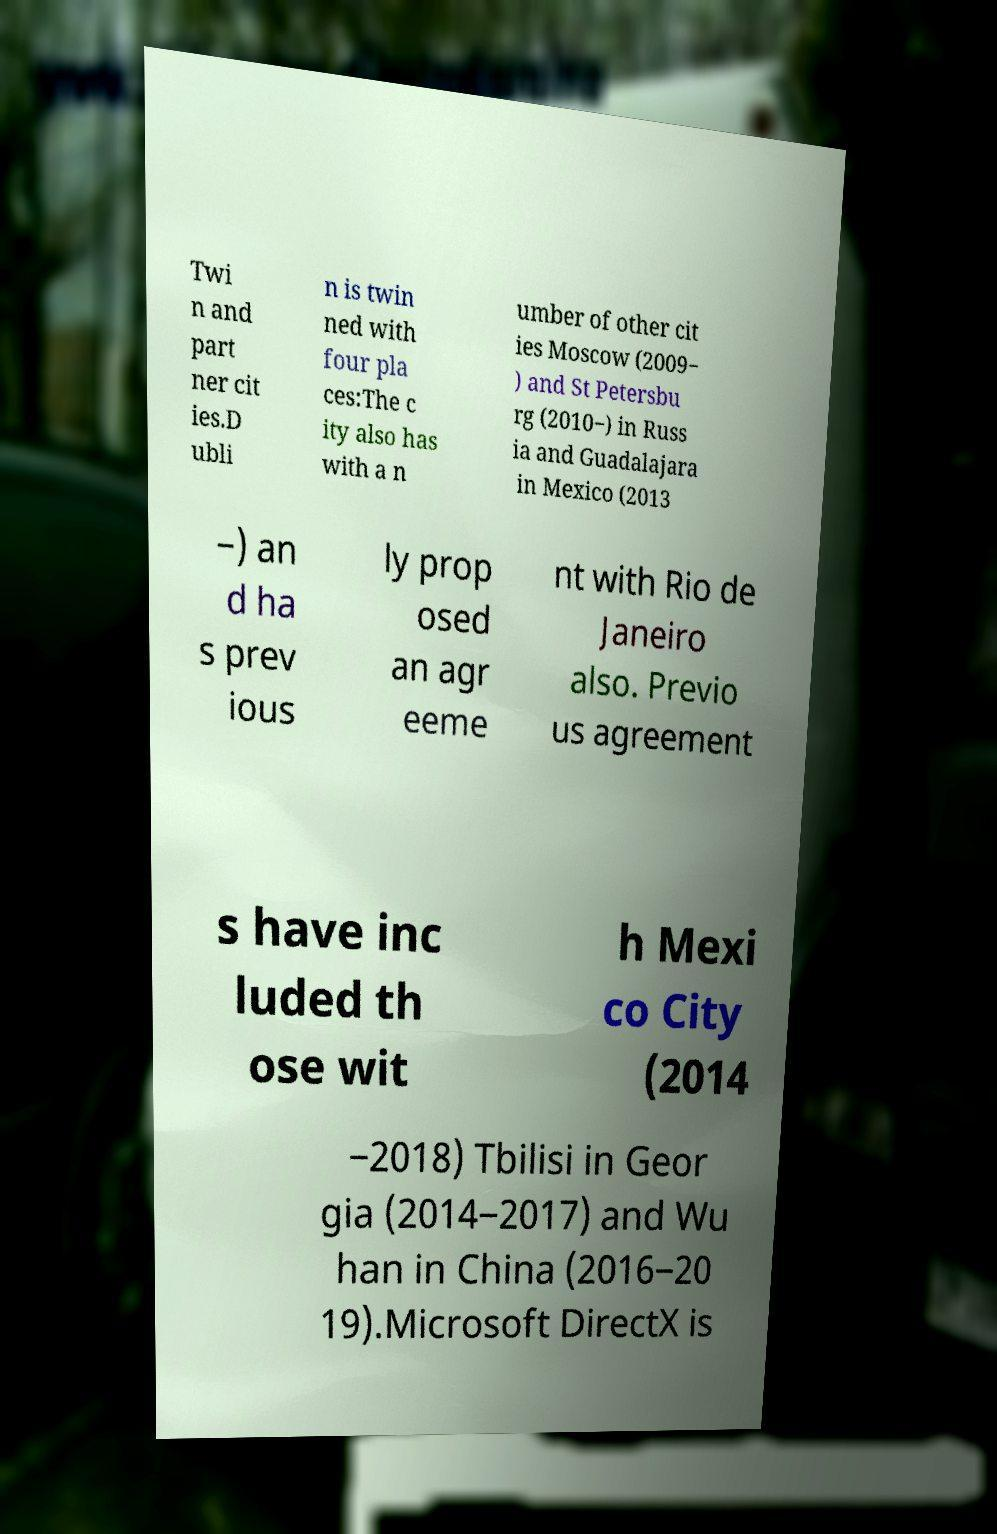I need the written content from this picture converted into text. Can you do that? Twi n and part ner cit ies.D ubli n is twin ned with four pla ces:The c ity also has with a n umber of other cit ies Moscow (2009− ) and St Petersbu rg (2010−) in Russ ia and Guadalajara in Mexico (2013 −) an d ha s prev ious ly prop osed an agr eeme nt with Rio de Janeiro also. Previo us agreement s have inc luded th ose wit h Mexi co City (2014 −2018) Tbilisi in Geor gia (2014−2017) and Wu han in China (2016−20 19).Microsoft DirectX is 